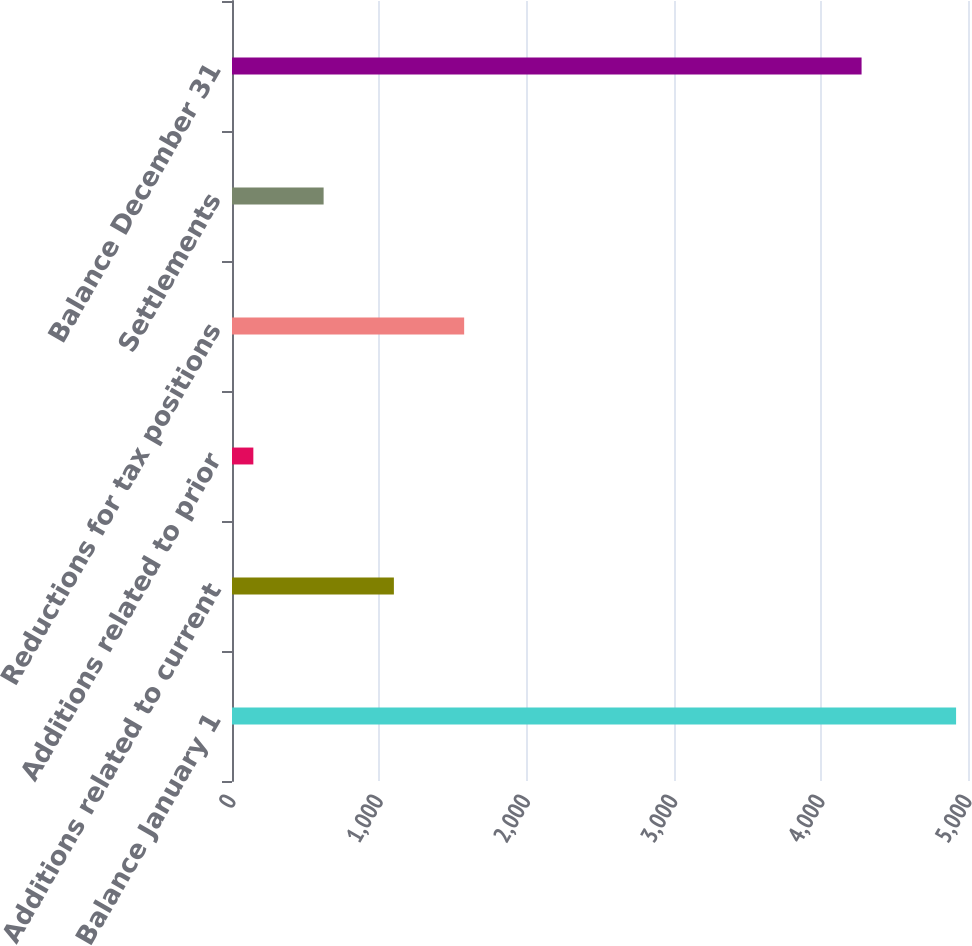Convert chart. <chart><loc_0><loc_0><loc_500><loc_500><bar_chart><fcel>Balance January 1<fcel>Additions related to current<fcel>Additions related to prior<fcel>Reductions for tax positions<fcel>Settlements<fcel>Balance December 31<nl><fcel>4919<fcel>1099.8<fcel>145<fcel>1577.2<fcel>622.4<fcel>4277<nl></chart> 